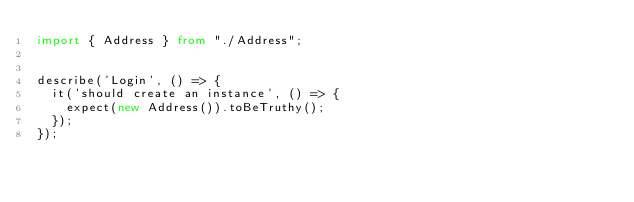<code> <loc_0><loc_0><loc_500><loc_500><_TypeScript_>import { Address } from "./Address";


describe('Login', () => {
  it('should create an instance', () => {
    expect(new Address()).toBeTruthy();
  });
});
</code> 